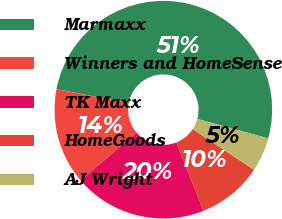<chart> <loc_0><loc_0><loc_500><loc_500><pie_chart><fcel>Marmaxx<fcel>Winners and HomeSense<fcel>TK Maxx<fcel>HomeGoods<fcel>AJ Wright<nl><fcel>51.23%<fcel>14.3%<fcel>19.73%<fcel>9.68%<fcel>5.07%<nl></chart> 